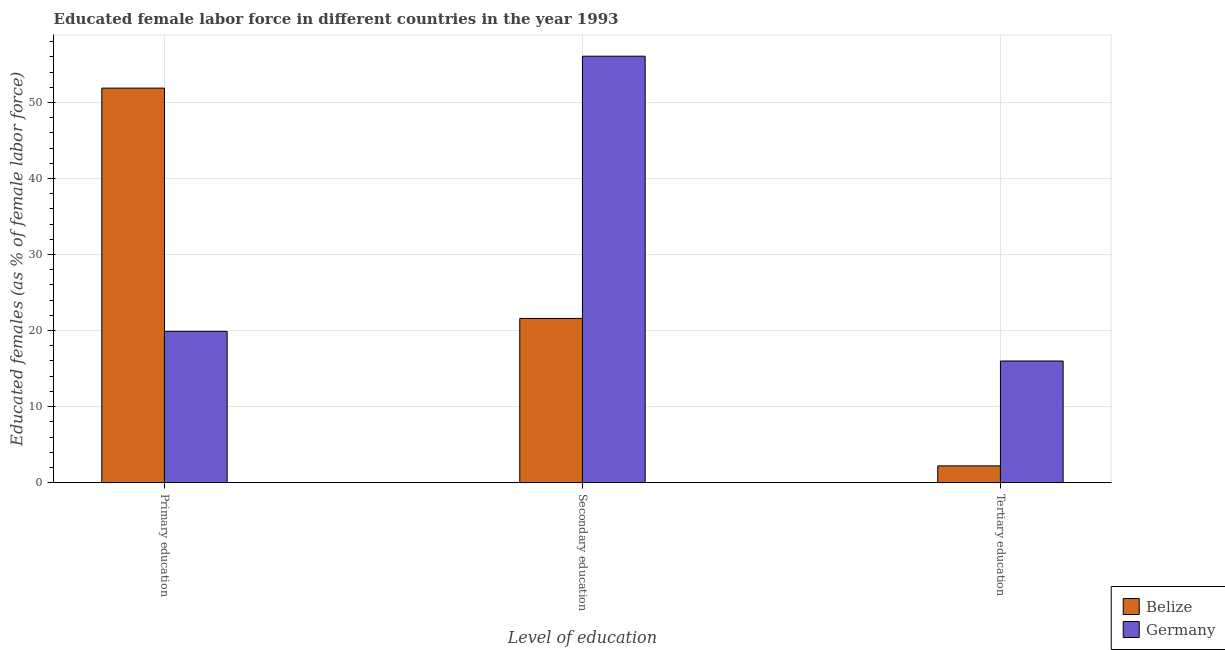How many groups of bars are there?
Make the answer very short. 3. Are the number of bars per tick equal to the number of legend labels?
Ensure brevity in your answer.  Yes. Are the number of bars on each tick of the X-axis equal?
Give a very brief answer. Yes. How many bars are there on the 3rd tick from the left?
Your answer should be compact. 2. What is the label of the 2nd group of bars from the left?
Your answer should be very brief. Secondary education. What is the percentage of female labor force who received tertiary education in Belize?
Offer a very short reply. 2.2. Across all countries, what is the maximum percentage of female labor force who received primary education?
Your response must be concise. 51.9. Across all countries, what is the minimum percentage of female labor force who received secondary education?
Your response must be concise. 21.6. In which country was the percentage of female labor force who received tertiary education maximum?
Your answer should be compact. Germany. What is the total percentage of female labor force who received secondary education in the graph?
Offer a terse response. 77.7. What is the difference between the percentage of female labor force who received secondary education in Belize and that in Germany?
Your response must be concise. -34.5. What is the difference between the percentage of female labor force who received tertiary education in Germany and the percentage of female labor force who received primary education in Belize?
Your answer should be compact. -35.9. What is the average percentage of female labor force who received tertiary education per country?
Give a very brief answer. 9.1. What is the difference between the percentage of female labor force who received primary education and percentage of female labor force who received tertiary education in Belize?
Give a very brief answer. 49.7. In how many countries, is the percentage of female labor force who received primary education greater than 28 %?
Offer a terse response. 1. What is the ratio of the percentage of female labor force who received tertiary education in Belize to that in Germany?
Your answer should be compact. 0.14. What is the difference between the highest and the second highest percentage of female labor force who received tertiary education?
Make the answer very short. 13.8. What is the difference between the highest and the lowest percentage of female labor force who received tertiary education?
Your answer should be compact. 13.8. Is the sum of the percentage of female labor force who received tertiary education in Belize and Germany greater than the maximum percentage of female labor force who received secondary education across all countries?
Offer a terse response. No. What does the 2nd bar from the right in Primary education represents?
Give a very brief answer. Belize. How many bars are there?
Your answer should be compact. 6. Are all the bars in the graph horizontal?
Provide a short and direct response. No. Does the graph contain any zero values?
Your response must be concise. No. Does the graph contain grids?
Provide a succinct answer. Yes. How many legend labels are there?
Provide a succinct answer. 2. What is the title of the graph?
Provide a short and direct response. Educated female labor force in different countries in the year 1993. What is the label or title of the X-axis?
Offer a terse response. Level of education. What is the label or title of the Y-axis?
Give a very brief answer. Educated females (as % of female labor force). What is the Educated females (as % of female labor force) of Belize in Primary education?
Your answer should be very brief. 51.9. What is the Educated females (as % of female labor force) of Germany in Primary education?
Provide a short and direct response. 19.9. What is the Educated females (as % of female labor force) in Belize in Secondary education?
Give a very brief answer. 21.6. What is the Educated females (as % of female labor force) in Germany in Secondary education?
Provide a succinct answer. 56.1. What is the Educated females (as % of female labor force) in Belize in Tertiary education?
Your answer should be compact. 2.2. Across all Level of education, what is the maximum Educated females (as % of female labor force) in Belize?
Offer a terse response. 51.9. Across all Level of education, what is the maximum Educated females (as % of female labor force) of Germany?
Keep it short and to the point. 56.1. Across all Level of education, what is the minimum Educated females (as % of female labor force) in Belize?
Your answer should be compact. 2.2. What is the total Educated females (as % of female labor force) of Belize in the graph?
Your response must be concise. 75.7. What is the total Educated females (as % of female labor force) of Germany in the graph?
Provide a succinct answer. 92. What is the difference between the Educated females (as % of female labor force) of Belize in Primary education and that in Secondary education?
Keep it short and to the point. 30.3. What is the difference between the Educated females (as % of female labor force) of Germany in Primary education and that in Secondary education?
Provide a succinct answer. -36.2. What is the difference between the Educated females (as % of female labor force) in Belize in Primary education and that in Tertiary education?
Provide a short and direct response. 49.7. What is the difference between the Educated females (as % of female labor force) in Germany in Primary education and that in Tertiary education?
Give a very brief answer. 3.9. What is the difference between the Educated females (as % of female labor force) in Belize in Secondary education and that in Tertiary education?
Your response must be concise. 19.4. What is the difference between the Educated females (as % of female labor force) of Germany in Secondary education and that in Tertiary education?
Provide a short and direct response. 40.1. What is the difference between the Educated females (as % of female labor force) in Belize in Primary education and the Educated females (as % of female labor force) in Germany in Secondary education?
Keep it short and to the point. -4.2. What is the difference between the Educated females (as % of female labor force) in Belize in Primary education and the Educated females (as % of female labor force) in Germany in Tertiary education?
Ensure brevity in your answer.  35.9. What is the difference between the Educated females (as % of female labor force) in Belize in Secondary education and the Educated females (as % of female labor force) in Germany in Tertiary education?
Your answer should be compact. 5.6. What is the average Educated females (as % of female labor force) in Belize per Level of education?
Keep it short and to the point. 25.23. What is the average Educated females (as % of female labor force) in Germany per Level of education?
Your answer should be very brief. 30.67. What is the difference between the Educated females (as % of female labor force) of Belize and Educated females (as % of female labor force) of Germany in Secondary education?
Provide a succinct answer. -34.5. What is the ratio of the Educated females (as % of female labor force) in Belize in Primary education to that in Secondary education?
Your answer should be very brief. 2.4. What is the ratio of the Educated females (as % of female labor force) of Germany in Primary education to that in Secondary education?
Your answer should be compact. 0.35. What is the ratio of the Educated females (as % of female labor force) in Belize in Primary education to that in Tertiary education?
Provide a short and direct response. 23.59. What is the ratio of the Educated females (as % of female labor force) in Germany in Primary education to that in Tertiary education?
Provide a short and direct response. 1.24. What is the ratio of the Educated females (as % of female labor force) of Belize in Secondary education to that in Tertiary education?
Provide a succinct answer. 9.82. What is the ratio of the Educated females (as % of female labor force) in Germany in Secondary education to that in Tertiary education?
Ensure brevity in your answer.  3.51. What is the difference between the highest and the second highest Educated females (as % of female labor force) of Belize?
Offer a terse response. 30.3. What is the difference between the highest and the second highest Educated females (as % of female labor force) of Germany?
Offer a terse response. 36.2. What is the difference between the highest and the lowest Educated females (as % of female labor force) in Belize?
Your answer should be compact. 49.7. What is the difference between the highest and the lowest Educated females (as % of female labor force) of Germany?
Ensure brevity in your answer.  40.1. 